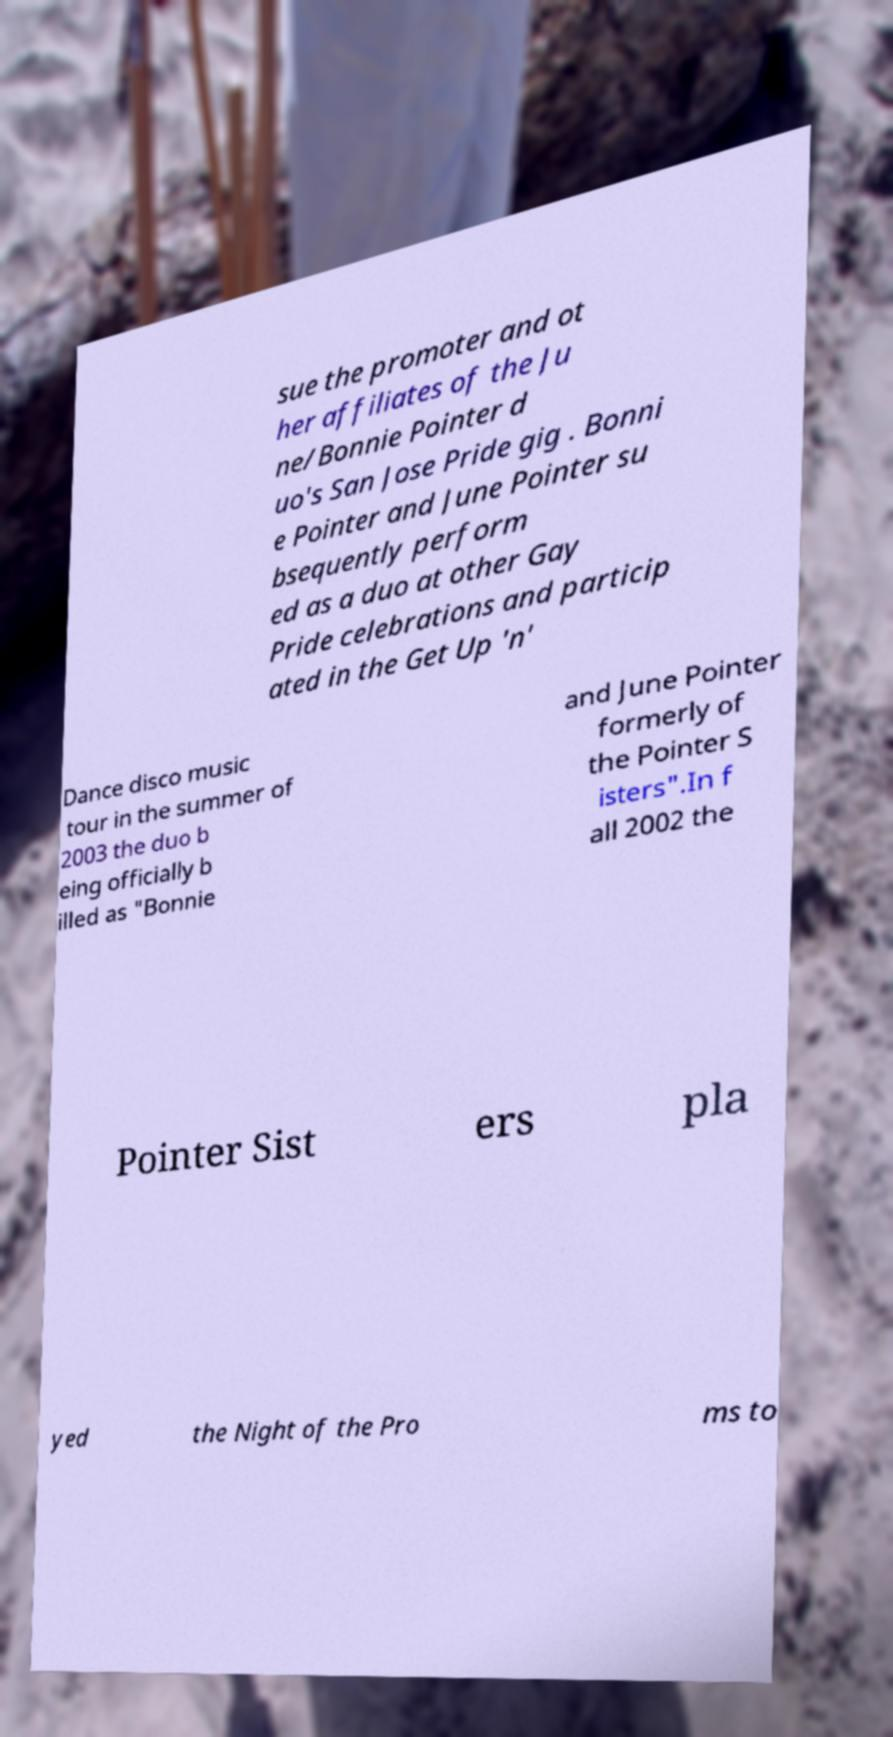Please identify and transcribe the text found in this image. sue the promoter and ot her affiliates of the Ju ne/Bonnie Pointer d uo's San Jose Pride gig . Bonni e Pointer and June Pointer su bsequently perform ed as a duo at other Gay Pride celebrations and particip ated in the Get Up 'n' Dance disco music tour in the summer of 2003 the duo b eing officially b illed as "Bonnie and June Pointer formerly of the Pointer S isters".In f all 2002 the Pointer Sist ers pla yed the Night of the Pro ms to 